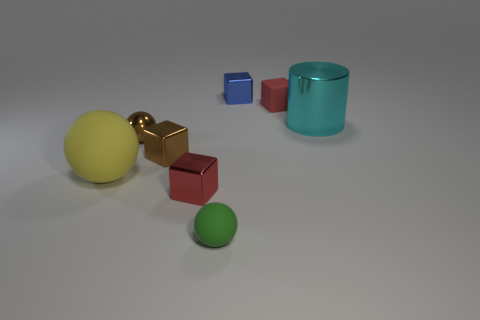Is the number of blocks that are in front of the yellow matte ball greater than the number of big purple metallic spheres?
Your answer should be compact. Yes. There is a large object that is on the left side of the tiny brown thing behind the brown metal cube; what is its color?
Your response must be concise. Yellow. How many objects are either shiny objects that are behind the cyan shiny object or metallic things behind the large yellow sphere?
Ensure brevity in your answer.  4. What is the color of the large matte object?
Offer a terse response. Yellow. What number of tiny brown cubes are made of the same material as the cylinder?
Your answer should be compact. 1. Are there more large rubber spheres than small yellow shiny balls?
Provide a succinct answer. Yes. There is a small blue metal block behind the large rubber sphere; how many brown things are right of it?
Provide a short and direct response. 0. What number of things are either small metallic things that are in front of the small rubber cube or tiny red rubber things?
Make the answer very short. 4. Is there another large red shiny object of the same shape as the red metal thing?
Offer a very short reply. No. The object right of the red block that is behind the large cylinder is what shape?
Ensure brevity in your answer.  Cylinder. 